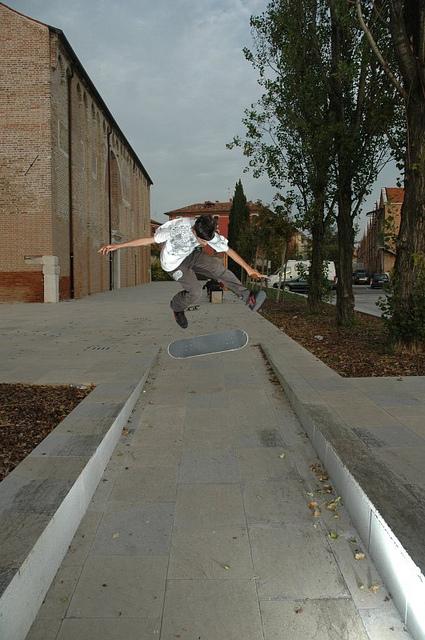What is the boy using?
Quick response, please. Skateboard. Is the boy flying?
Write a very short answer. No. What is the boy doing?
Concise answer only. Skateboarding. 